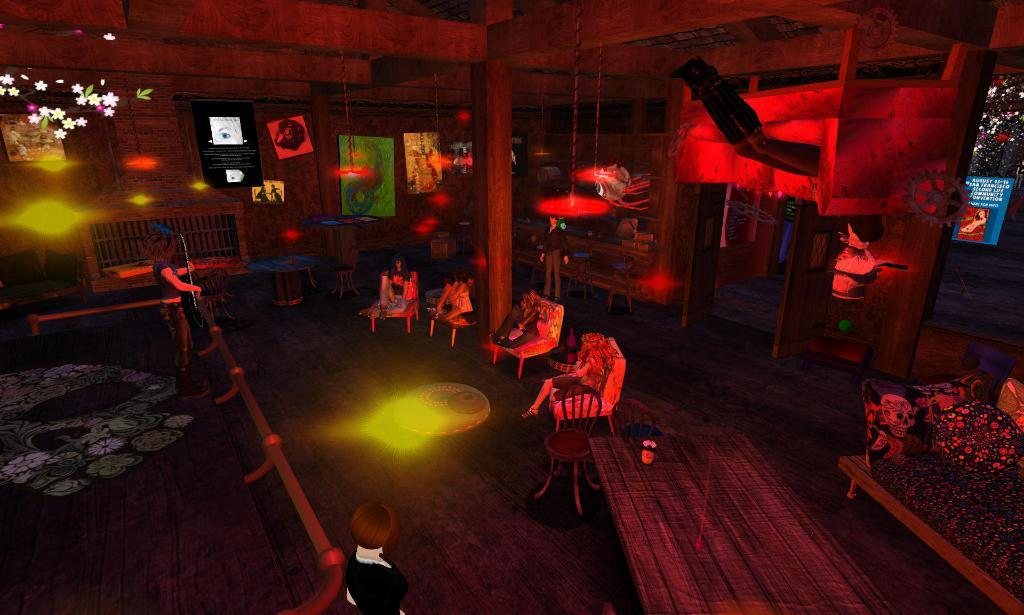What type of work is the yoke doing in the image? There is no yoke present in the image, so it is not possible to answer that question. What type of work is the yoke doing in the image? There is no yoke present in the image, so it is not possible to answer that question. Reasoning: Let's think step by step in order to create an absurd question. We start by selecting one of the given topics, which is "yoke." Then, we formulate a question that involves the yoke in a way that is not present in the image, making it an absurd question. In this case, we asked about the work the yoke is doing, even though there is no yoke present in the image. 